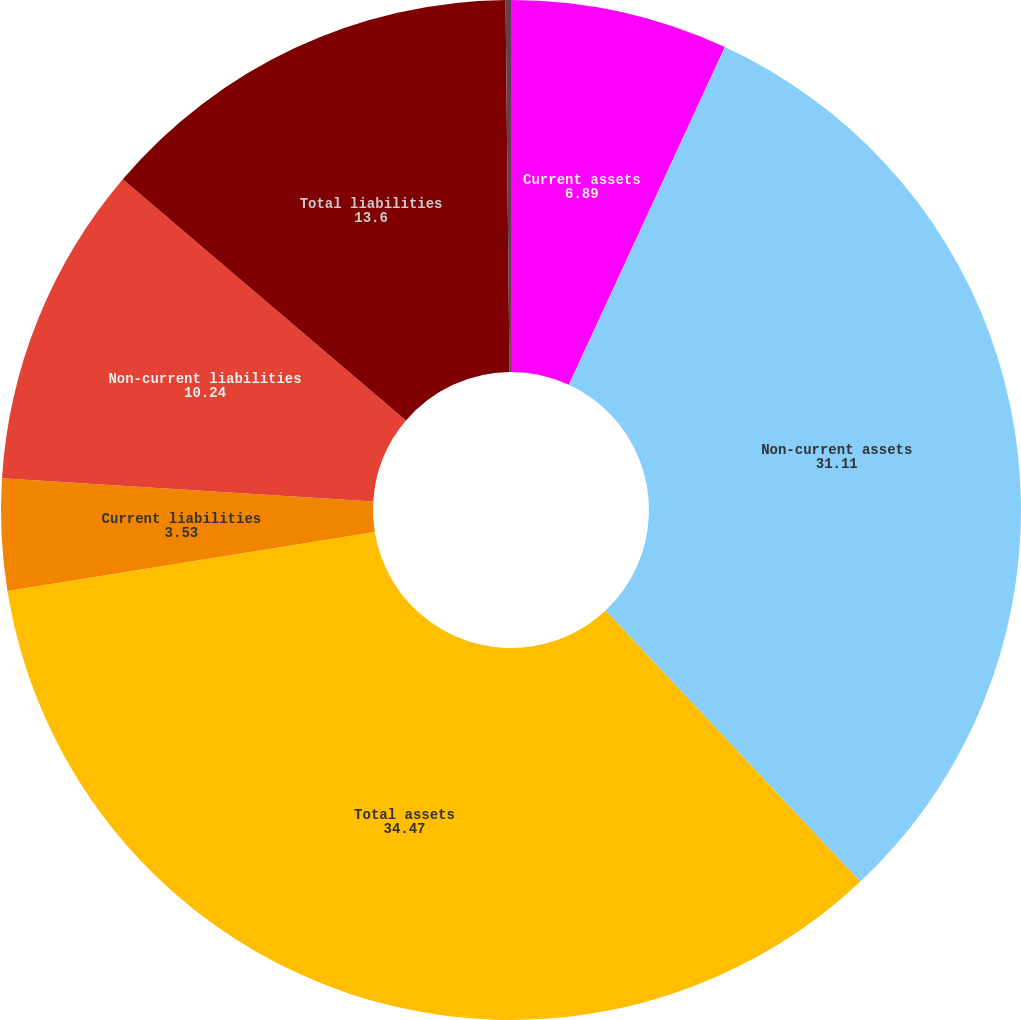<chart> <loc_0><loc_0><loc_500><loc_500><pie_chart><fcel>Current assets<fcel>Non-current assets<fcel>Total assets<fcel>Current liabilities<fcel>Non-current liabilities<fcel>Total liabilities<fcel>Non-controlling interests<nl><fcel>6.89%<fcel>31.11%<fcel>34.47%<fcel>3.53%<fcel>10.24%<fcel>13.6%<fcel>0.17%<nl></chart> 